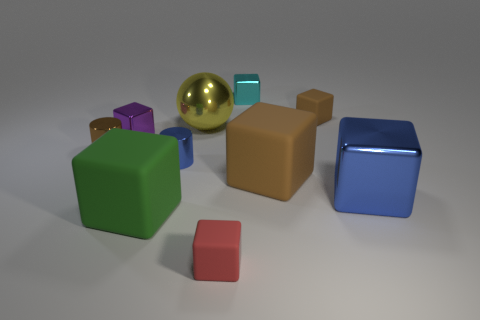Subtract all metallic cubes. How many cubes are left? 4 Subtract all purple blocks. How many blocks are left? 6 Subtract all cylinders. How many objects are left? 8 Subtract 2 blocks. How many blocks are left? 5 Subtract 0 gray blocks. How many objects are left? 10 Subtract all red cylinders. Subtract all red spheres. How many cylinders are left? 2 Subtract all purple cylinders. How many purple cubes are left? 1 Subtract all brown metallic objects. Subtract all tiny metal blocks. How many objects are left? 7 Add 5 tiny purple cubes. How many tiny purple cubes are left? 6 Add 8 big purple metal cubes. How many big purple metal cubes exist? 8 